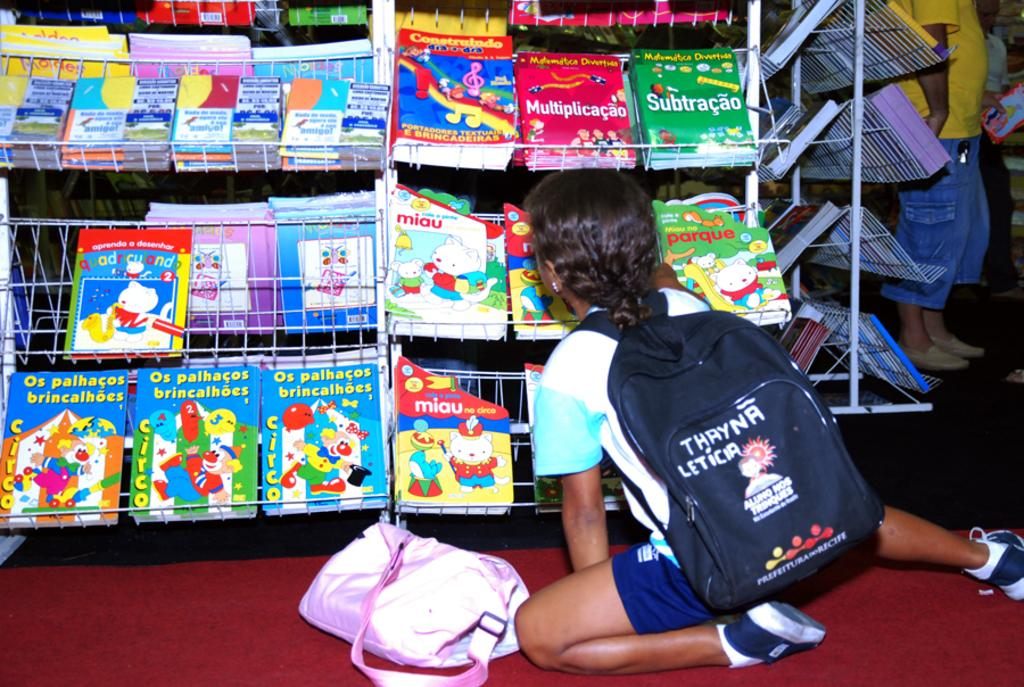<image>
Present a compact description of the photo's key features. A girl with a backpack that says Thayna Letica is looking at books on a shelf. 